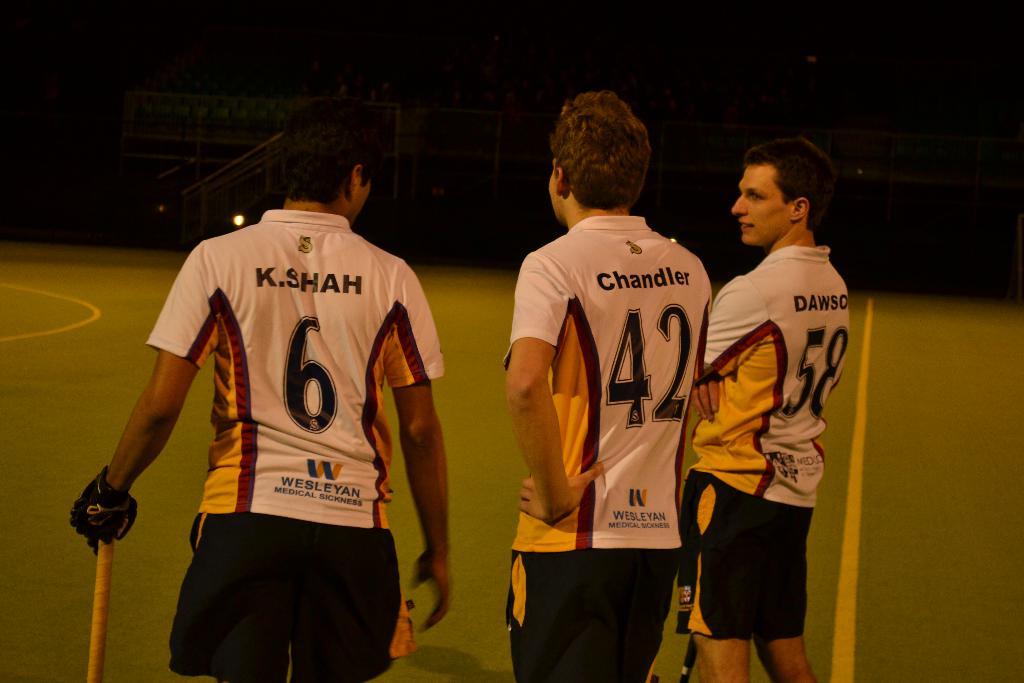What's the name of player 42?
Offer a very short reply. Chandler. What number shirt is the person on the left?
Offer a very short reply. 6. 